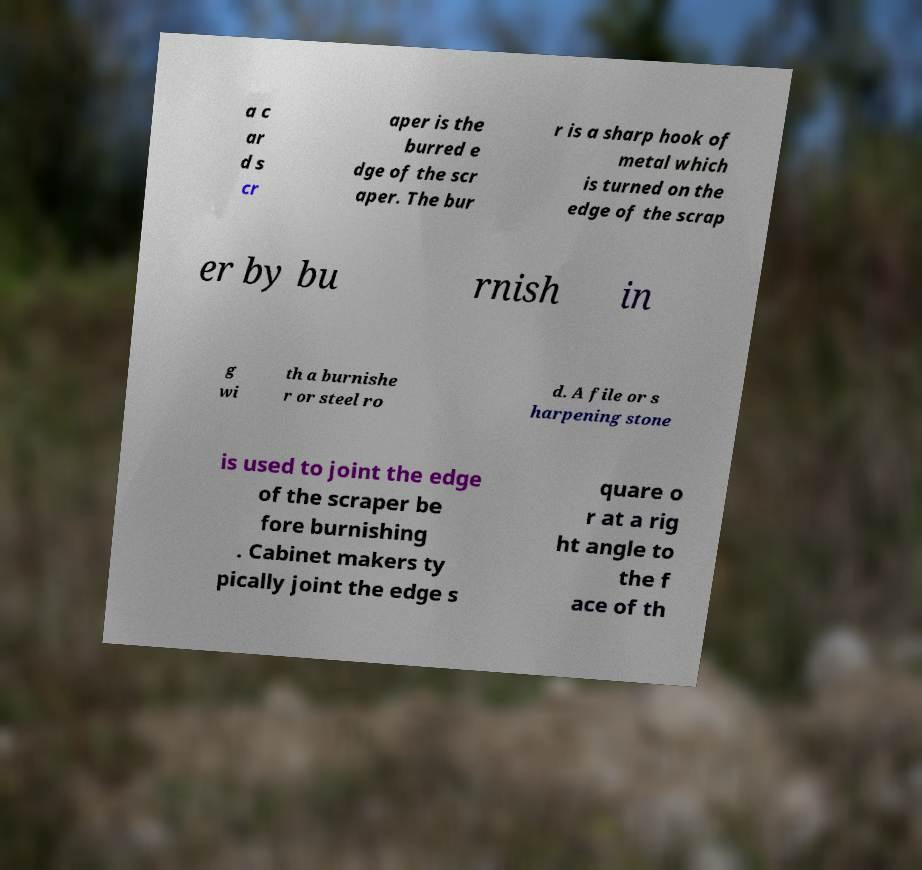What messages or text are displayed in this image? I need them in a readable, typed format. a c ar d s cr aper is the burred e dge of the scr aper. The bur r is a sharp hook of metal which is turned on the edge of the scrap er by bu rnish in g wi th a burnishe r or steel ro d. A file or s harpening stone is used to joint the edge of the scraper be fore burnishing . Cabinet makers ty pically joint the edge s quare o r at a rig ht angle to the f ace of th 